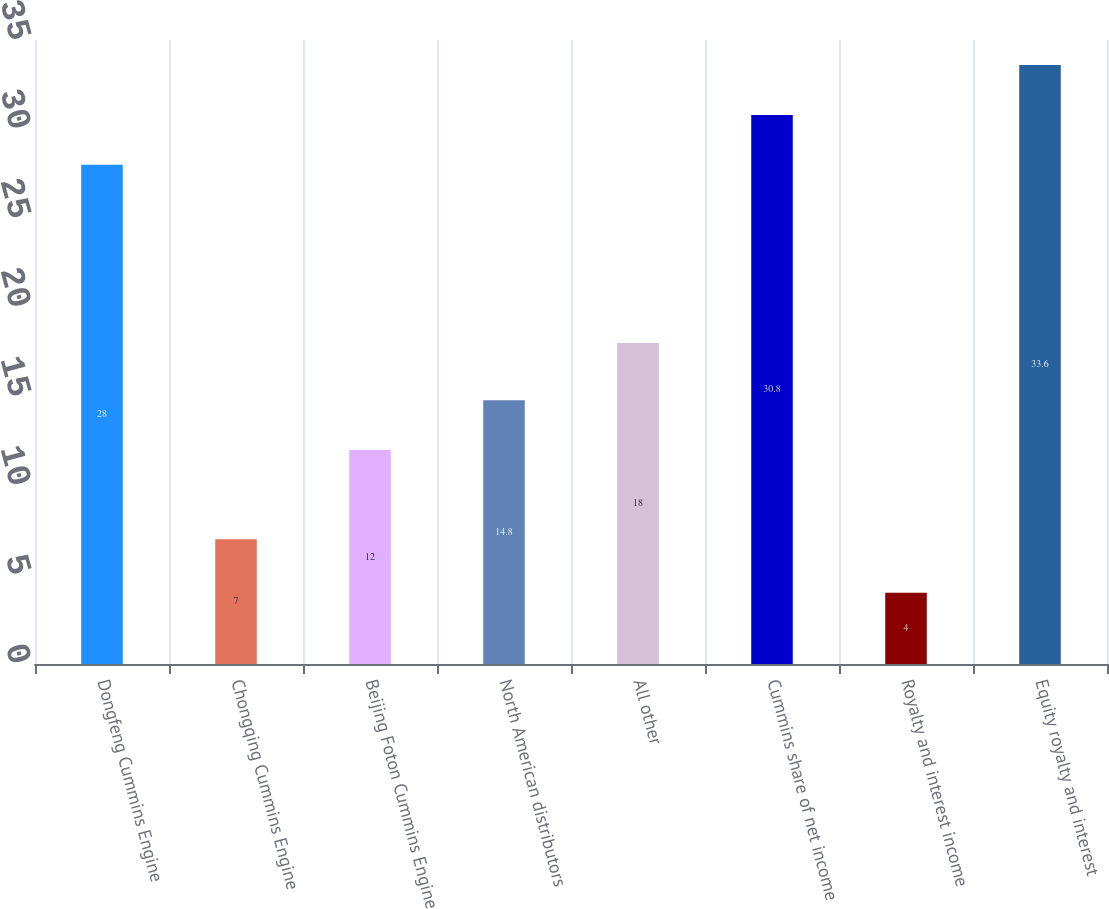Convert chart. <chart><loc_0><loc_0><loc_500><loc_500><bar_chart><fcel>Dongfeng Cummins Engine<fcel>Chongqing Cummins Engine<fcel>Beijing Foton Cummins Engine<fcel>North American distributors<fcel>All other<fcel>Cummins share of net income<fcel>Royalty and interest income<fcel>Equity royalty and interest<nl><fcel>28<fcel>7<fcel>12<fcel>14.8<fcel>18<fcel>30.8<fcel>4<fcel>33.6<nl></chart> 